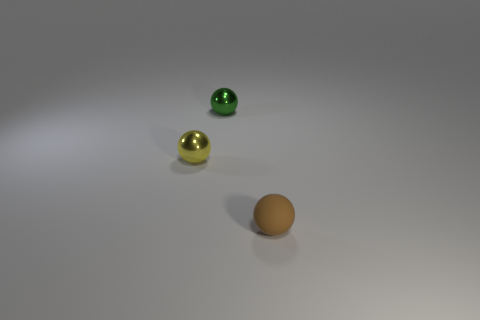Add 1 metal things. How many objects exist? 4 Add 3 rubber spheres. How many rubber spheres are left? 4 Add 2 brown objects. How many brown objects exist? 3 Subtract 0 cyan blocks. How many objects are left? 3 Subtract all small metal things. Subtract all small yellow metal balls. How many objects are left? 0 